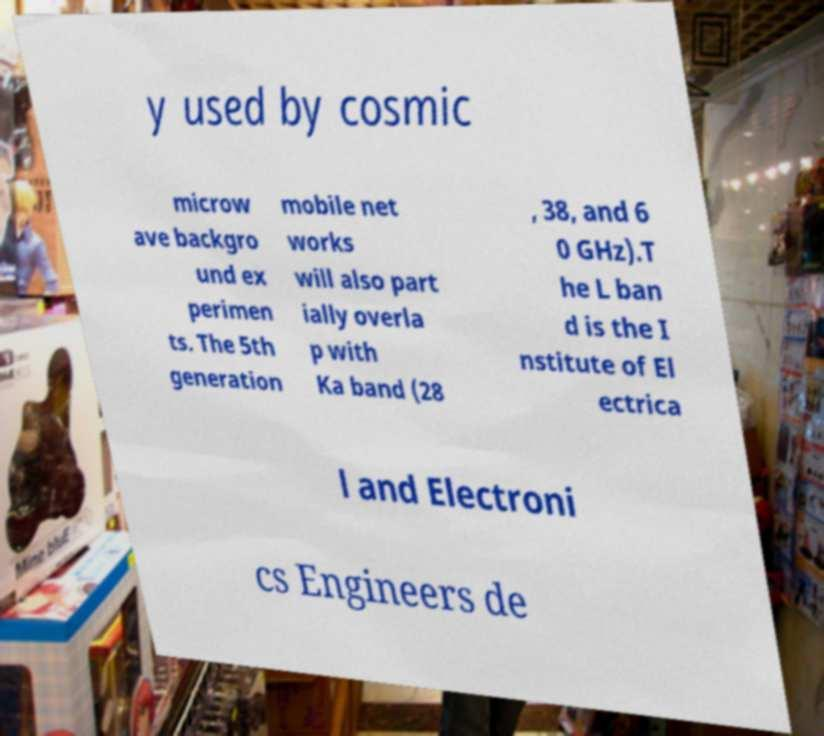What messages or text are displayed in this image? I need them in a readable, typed format. y used by cosmic microw ave backgro und ex perimen ts. The 5th generation mobile net works will also part ially overla p with Ka band (28 , 38, and 6 0 GHz).T he L ban d is the I nstitute of El ectrica l and Electroni cs Engineers de 